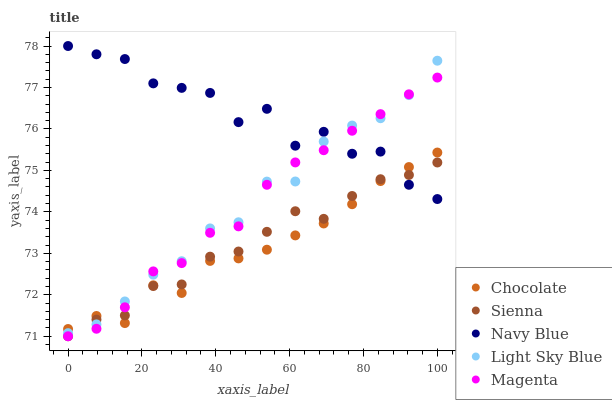Does Chocolate have the minimum area under the curve?
Answer yes or no. Yes. Does Navy Blue have the maximum area under the curve?
Answer yes or no. Yes. Does Magenta have the minimum area under the curve?
Answer yes or no. No. Does Magenta have the maximum area under the curve?
Answer yes or no. No. Is Magenta the smoothest?
Answer yes or no. Yes. Is Navy Blue the roughest?
Answer yes or no. Yes. Is Navy Blue the smoothest?
Answer yes or no. No. Is Magenta the roughest?
Answer yes or no. No. Does Sienna have the lowest value?
Answer yes or no. Yes. Does Navy Blue have the lowest value?
Answer yes or no. No. Does Navy Blue have the highest value?
Answer yes or no. Yes. Does Magenta have the highest value?
Answer yes or no. No. Does Magenta intersect Chocolate?
Answer yes or no. Yes. Is Magenta less than Chocolate?
Answer yes or no. No. Is Magenta greater than Chocolate?
Answer yes or no. No. 